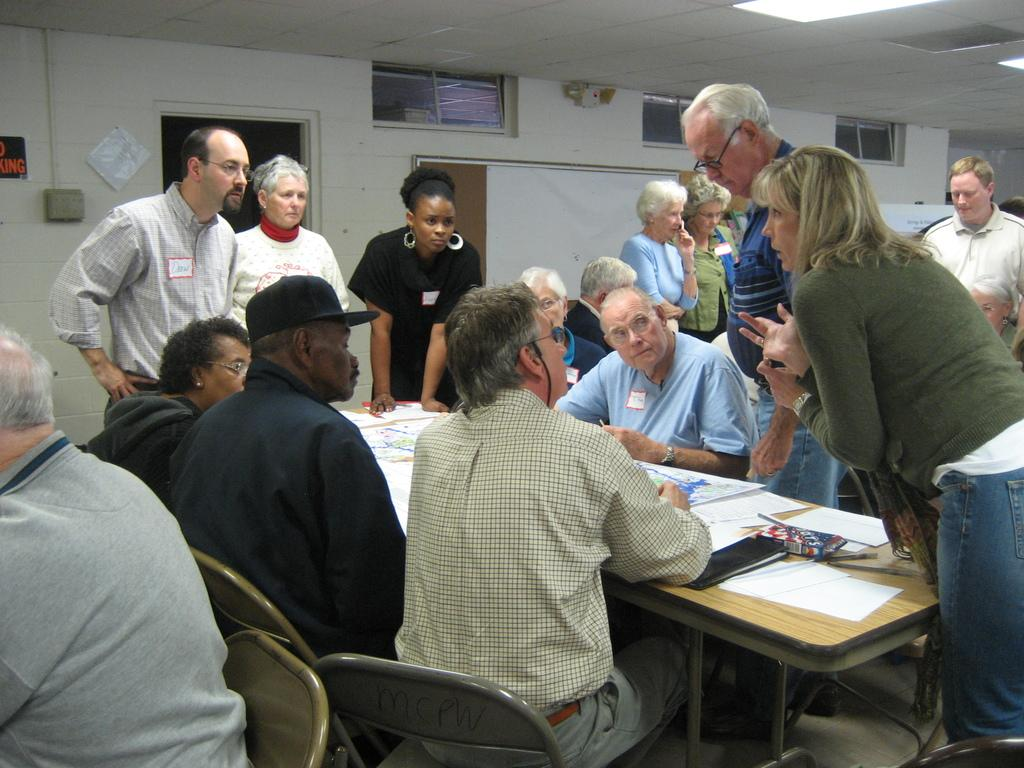What are the people in the image doing? There is a group of people sitting on chairs in the image. Where are the chairs located in relation to the table? The chairs are in front of a table. What are the people on the floor doing? There are people standing on the floor in the image. What can be seen on the table? There are objects on the table. What type of toothbrush is being used by the person sitting on the chair? There is no toothbrush present in the image. Is the wine served in glasses on the table? There is no wine or glasses present in the image. 